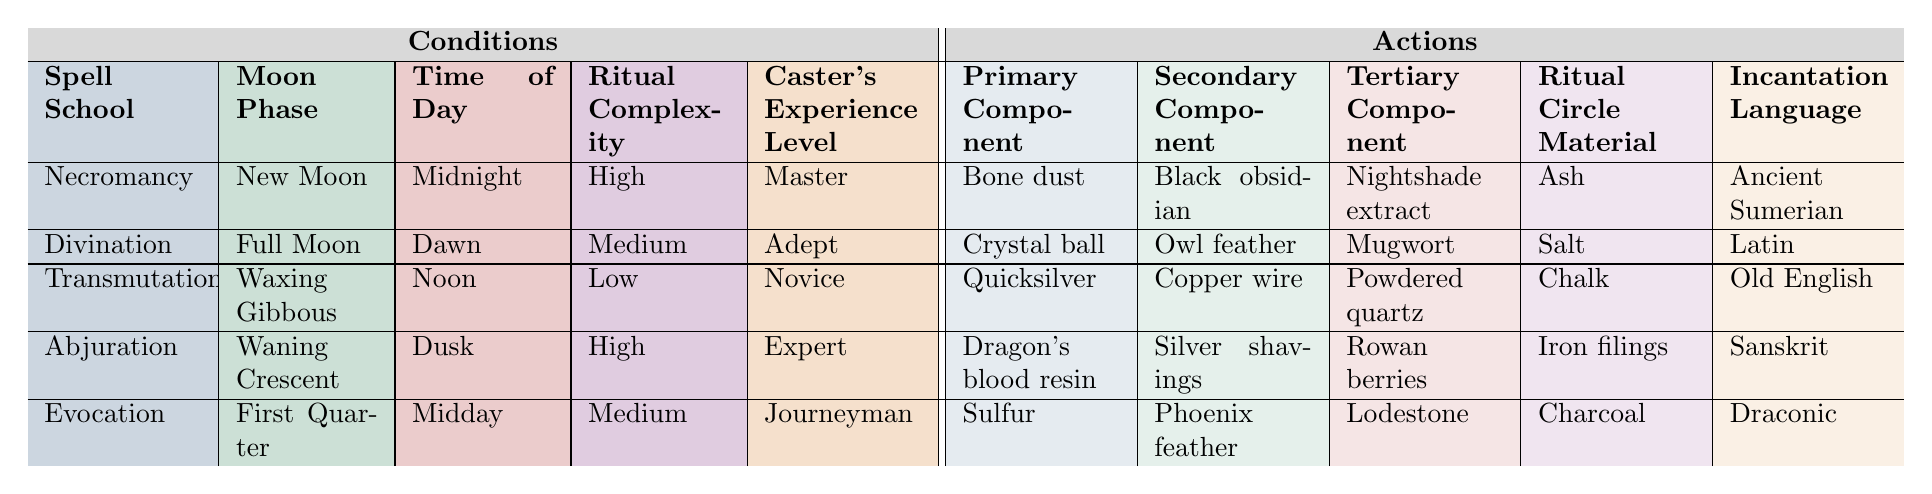What is the primary component for the Evocation school? The table lists the Primary Component in the Evocation row, which is Sulfur.
Answer: Sulfur What incantation language is used for Necromancy rituals? By checking the Necromancy row in the table, the Incantation Language specified is Ancient Sumerian.
Answer: Ancient Sumerian Is the Ritual Complexity for Divination High? Looking at the Divination row, the Ritual Complexity is Medium, so the statement is false.
Answer: No Which spell school requires Dragon's blood resin as the Primary Component? Referring to the table, in the Abjuration row, Dragon's blood resin is listed as the Primary Component.
Answer: Abjuration For which ritual timing is Quicksilver the Primary Component? In the table, Quicksilver is listed as the Primary Component under the Transmutation row, with the timing being Noon.
Answer: Transmutation at Noon What is the average experience level of the casters for the listed spells? The experience levels are Master, Adept, Novice, Expert, and Journeyman, which correspond to 5 (Master) + 4 (Adept) + 1 (Novice) + 4 (Expert) + 3 (Journeyman) = 17. Dividing by the number of spells (5), gives an average experience level of 3.4, which, if we assign numeric values to levels, corresponds to an approximate level between Adept and Journeyman.
Answer: Approximately 3.4 Is the time of day for Abjuration rituals more complex than that of Transmutation? The Abjuration time is Dusk and the Transmutation time is Noon. Both have High and Low complexities respectively, indicating that Dusk is used for more complex rituals. Therefore, the statement is true.
Answer: Yes If one were to perform a ritual during the Full Moon, which spell school would apply? Looking at the Moon Phase column, under Full Moon, the corresponding spell school is Divination.
Answer: Divination 